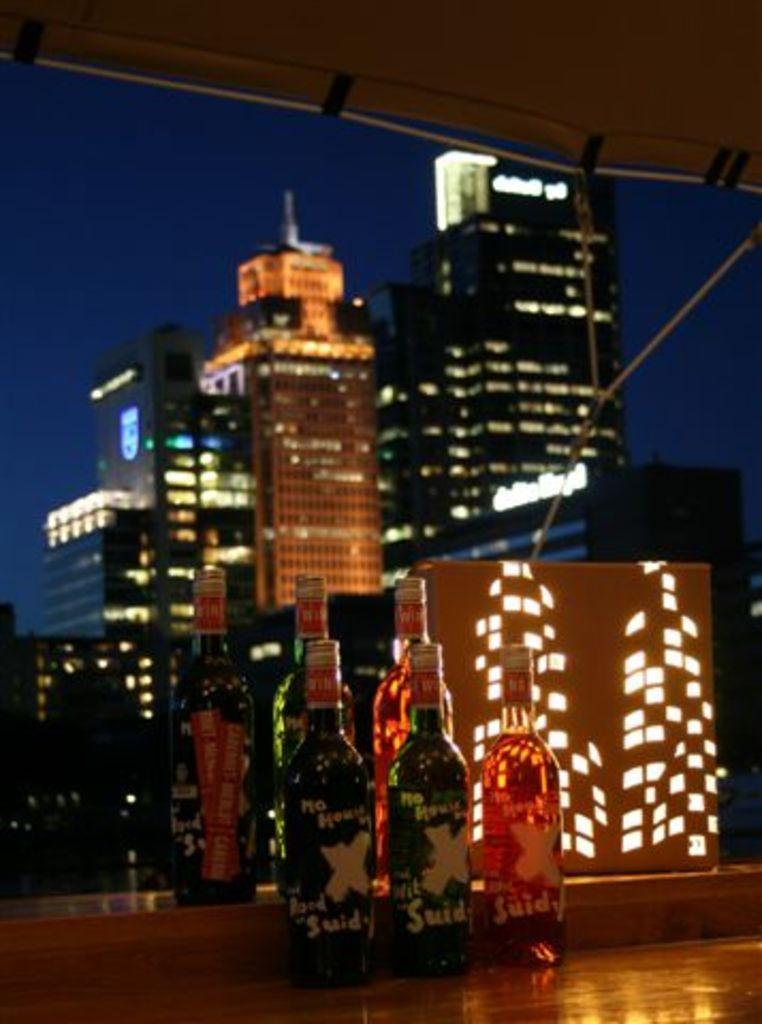How many wine bottles are present in the image? There are six wine bottles in the image. What is the surface on which the wine bottles are placed? The wine bottles are on a wooden table. What type of structure can be seen in the background of the image? There is a building visible in the image. What is the condition of the sky in the image? The sky is clear in the image. What type of family is depicted in the image? There is no family depicted in the image; it features six wine bottles on a wooden table with a building and clear sky in the background. 